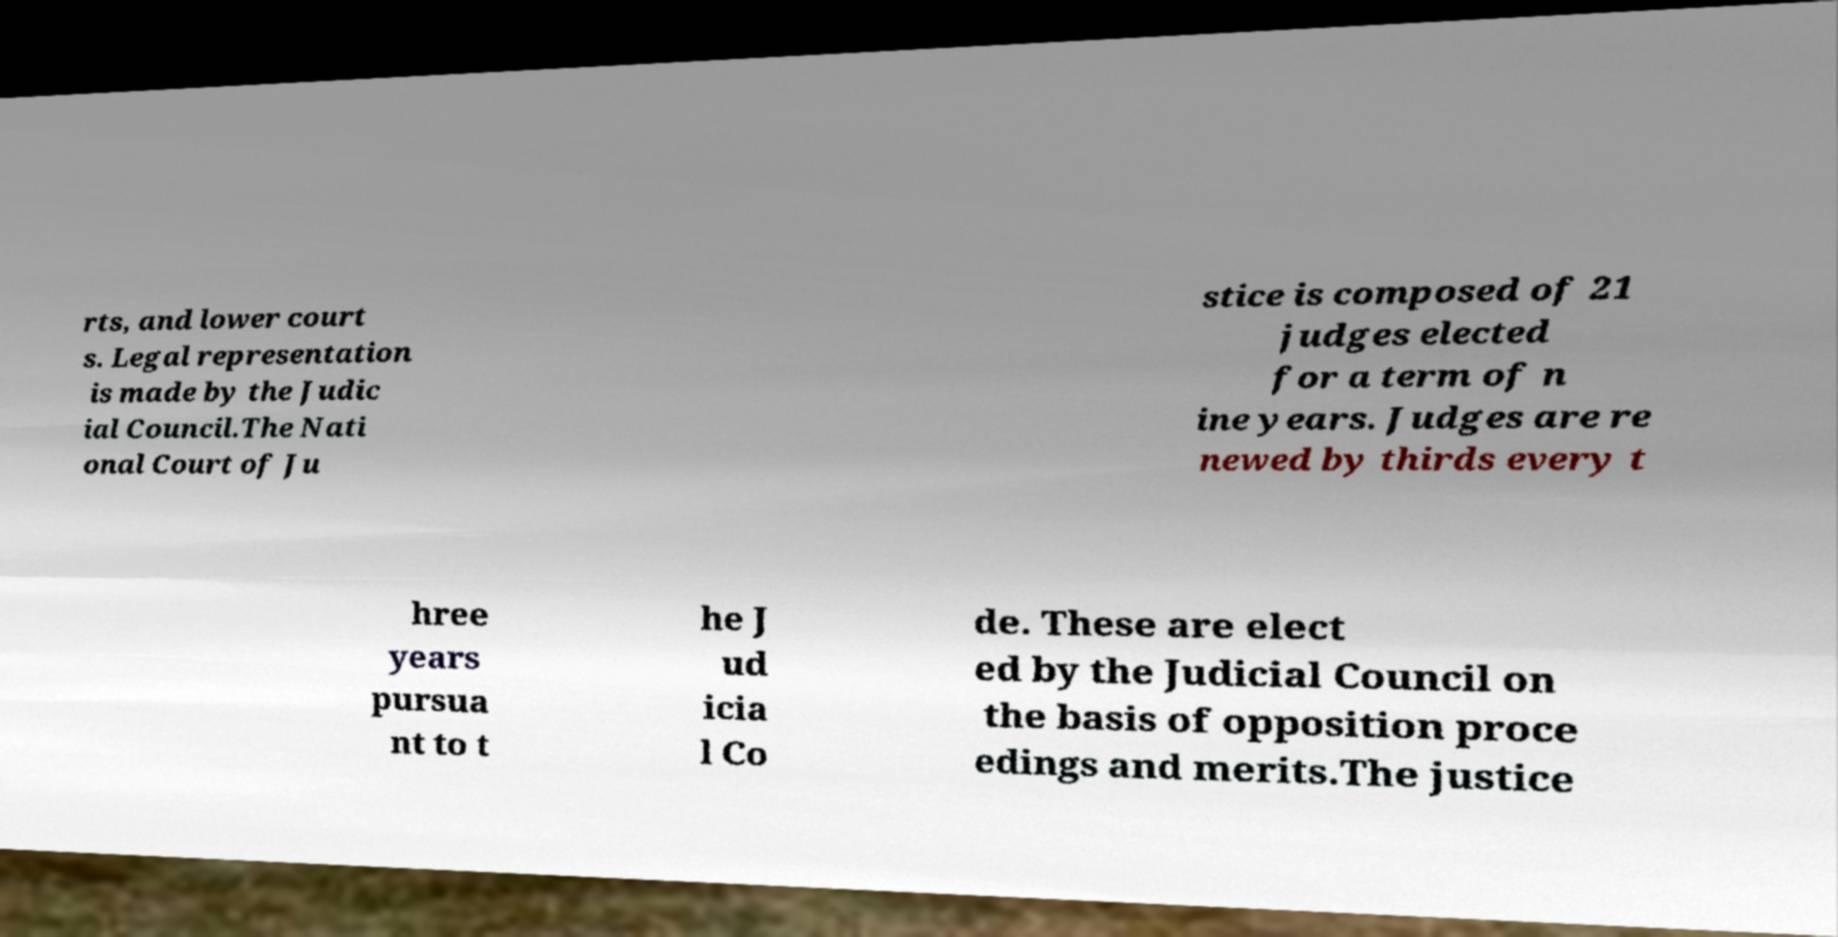There's text embedded in this image that I need extracted. Can you transcribe it verbatim? rts, and lower court s. Legal representation is made by the Judic ial Council.The Nati onal Court of Ju stice is composed of 21 judges elected for a term of n ine years. Judges are re newed by thirds every t hree years pursua nt to t he J ud icia l Co de. These are elect ed by the Judicial Council on the basis of opposition proce edings and merits.The justice 